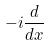Convert formula to latex. <formula><loc_0><loc_0><loc_500><loc_500>- i \frac { d } { d x }</formula> 